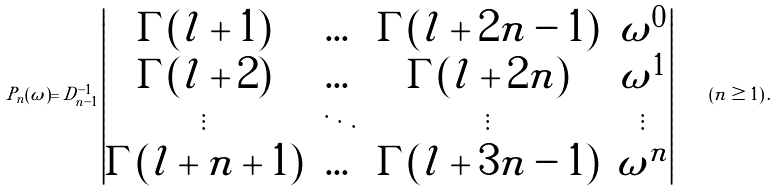<formula> <loc_0><loc_0><loc_500><loc_500>P _ { n } ( \omega ) = D _ { n - 1 } ^ { - 1 } \left | \begin{matrix} \Gamma ( l + 1 ) & \dots & \Gamma ( l + 2 n - 1 ) & \omega ^ { 0 } \\ \Gamma ( l + 2 ) & \dots & \Gamma ( l + 2 n ) & \omega ^ { 1 } \\ \vdots & \ddots & \vdots & \vdots \\ \Gamma ( l + n + 1 ) & \dots & \Gamma ( l + 3 n - 1 ) & \omega ^ { n } \end{matrix} \right | \quad ( n \geq 1 ) \, .</formula> 